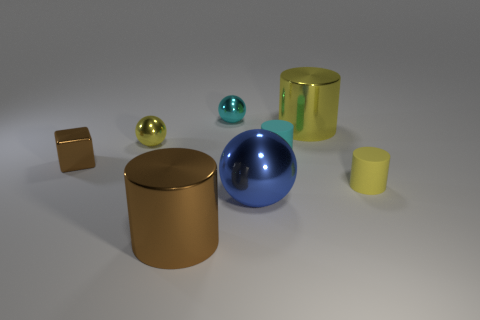There is a cylinder that is left of the large yellow cylinder and behind the big metallic ball; what material is it made of?
Keep it short and to the point. Rubber. Do the large brown object and the yellow thing in front of the cube have the same material?
Give a very brief answer. No. What number of objects are big blue balls or large metal cylinders behind the tiny cyan cylinder?
Give a very brief answer. 2. Does the brown thing on the right side of the small yellow sphere have the same size as the yellow shiny thing that is right of the cyan cylinder?
Your response must be concise. Yes. How many other things are there of the same color as the large ball?
Give a very brief answer. 0. There is a brown cube; is it the same size as the yellow shiny thing behind the tiny yellow metal sphere?
Your answer should be compact. No. What size is the metal cylinder behind the brown shiny object that is on the left side of the large brown cylinder?
Offer a very short reply. Large. There is another small shiny object that is the same shape as the small yellow shiny thing; what is its color?
Provide a succinct answer. Cyan. Do the yellow shiny cylinder and the blue metal sphere have the same size?
Give a very brief answer. Yes. Are there an equal number of large brown things right of the big yellow cylinder and big red metal cylinders?
Provide a succinct answer. Yes. 